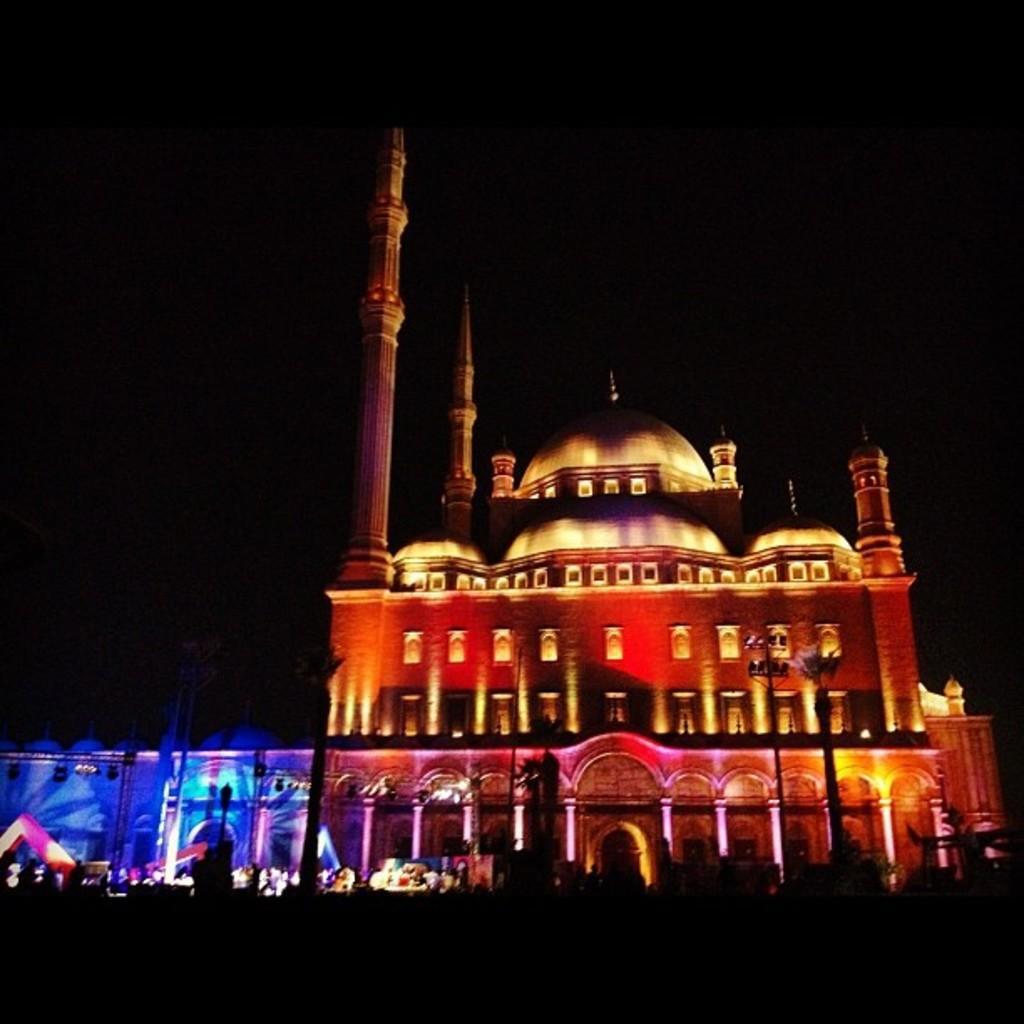How would you summarize this image in a sentence or two? In this image we can see a building with lights and the background is dark. 